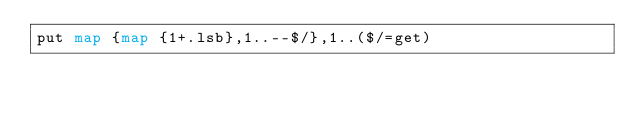Convert code to text. <code><loc_0><loc_0><loc_500><loc_500><_Perl_>put map {map {1+.lsb},1..--$/},1..($/=get)</code> 